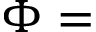<formula> <loc_0><loc_0><loc_500><loc_500>\Phi =</formula> 